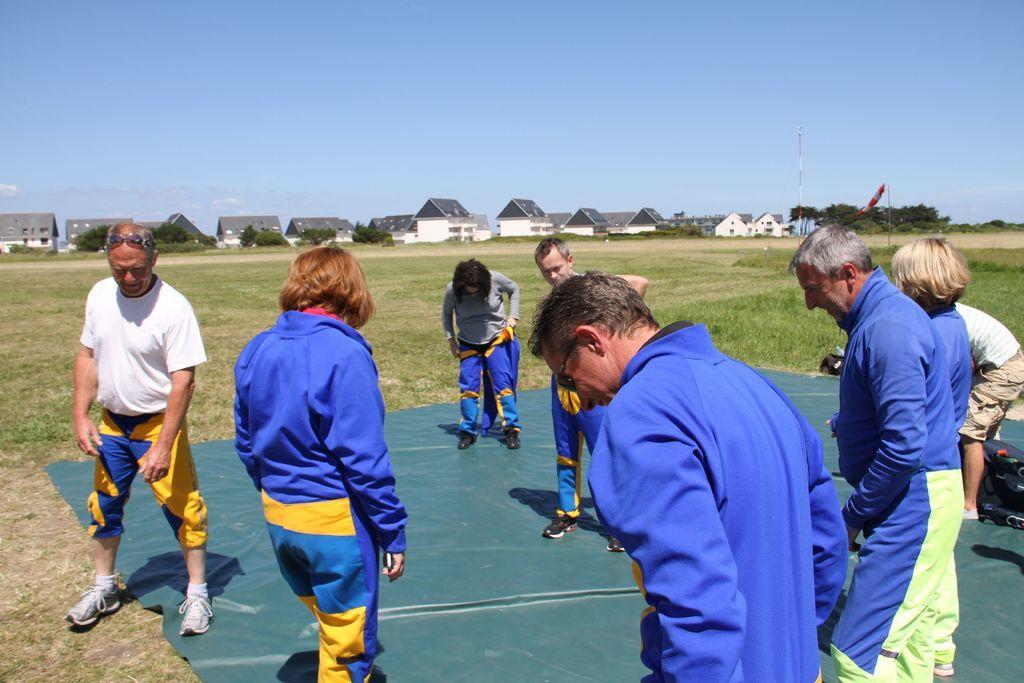Describe this image in one or two sentences. In this image there are few people visible on the ground, in the middle there are some houses, poles, trees, at the top there is the sky. 